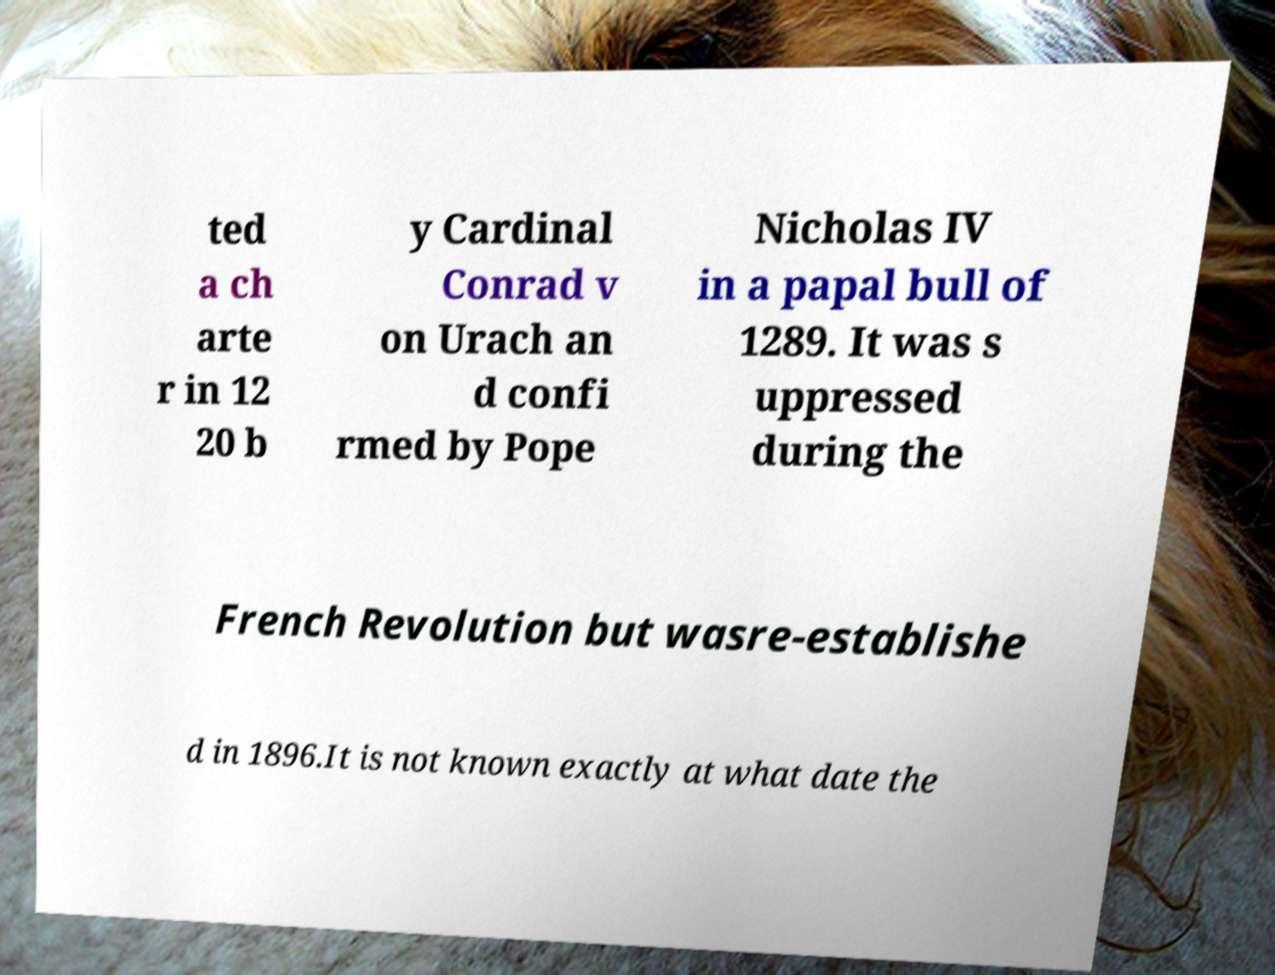Can you accurately transcribe the text from the provided image for me? ted a ch arte r in 12 20 b y Cardinal Conrad v on Urach an d confi rmed by Pope Nicholas IV in a papal bull of 1289. It was s uppressed during the French Revolution but wasre-establishe d in 1896.It is not known exactly at what date the 